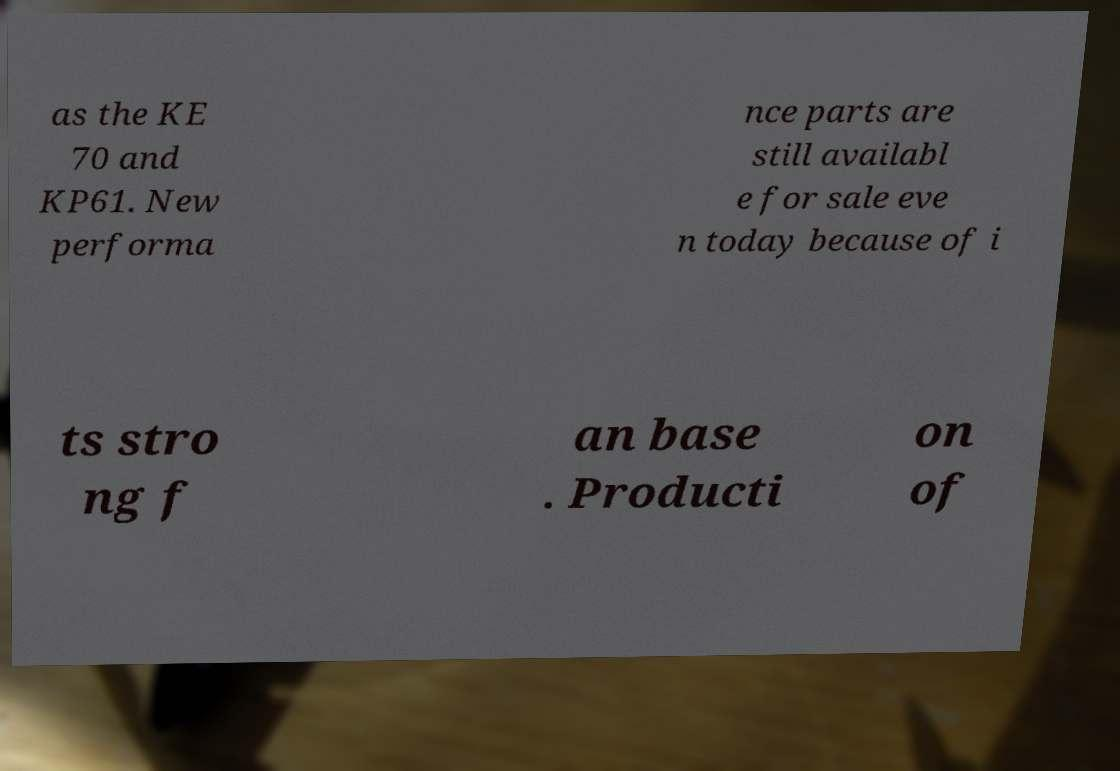I need the written content from this picture converted into text. Can you do that? as the KE 70 and KP61. New performa nce parts are still availabl e for sale eve n today because of i ts stro ng f an base . Producti on of 